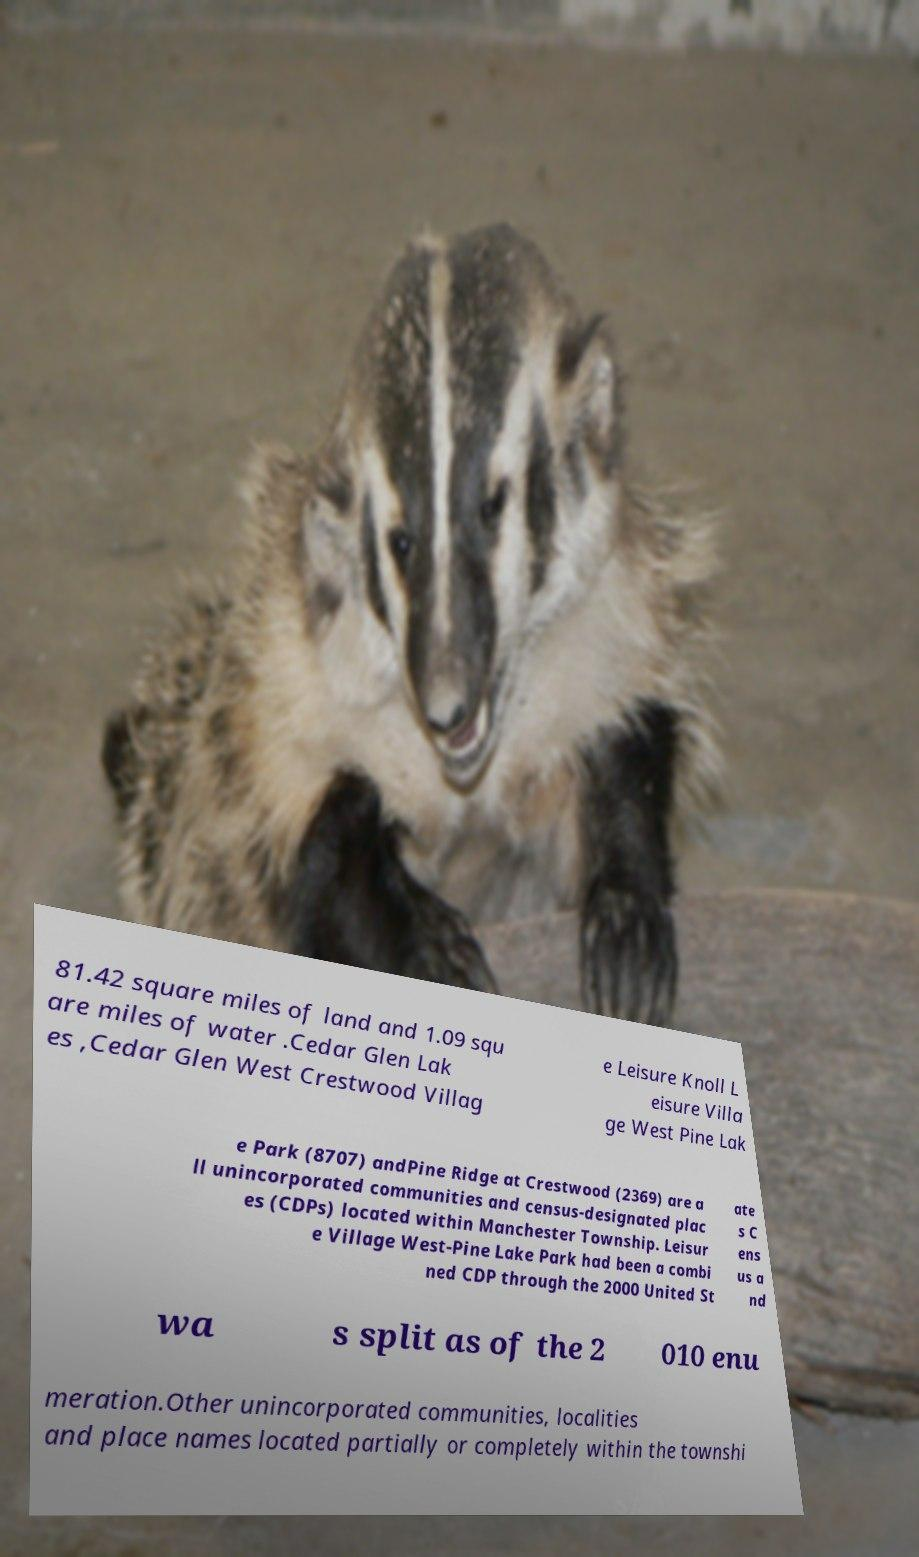Can you read and provide the text displayed in the image?This photo seems to have some interesting text. Can you extract and type it out for me? 81.42 square miles of land and 1.09 squ are miles of water .Cedar Glen Lak es ,Cedar Glen West Crestwood Villag e Leisure Knoll L eisure Villa ge West Pine Lak e Park (8707) andPine Ridge at Crestwood (2369) are a ll unincorporated communities and census-designated plac es (CDPs) located within Manchester Township. Leisur e Village West-Pine Lake Park had been a combi ned CDP through the 2000 United St ate s C ens us a nd wa s split as of the 2 010 enu meration.Other unincorporated communities, localities and place names located partially or completely within the townshi 